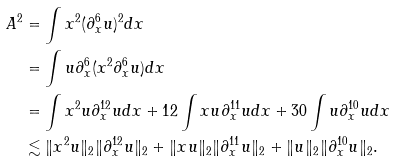Convert formula to latex. <formula><loc_0><loc_0><loc_500><loc_500>A ^ { 2 } & = \int x ^ { 2 } ( \partial _ { x } ^ { 6 } u ) ^ { 2 } d x \\ & = \int u \partial _ { x } ^ { 6 } ( x ^ { 2 } \partial _ { x } ^ { 6 } u ) d x \\ & = \int x ^ { 2 } u \partial _ { x } ^ { 1 2 } u d x + 1 2 \int x u \partial _ { x } ^ { 1 1 } u d x + 3 0 \int u \partial _ { x } ^ { 1 0 } u d x \\ & \lesssim \| x ^ { 2 } u \| _ { 2 } \| \partial _ { x } ^ { 1 2 } u \| _ { 2 } + \| x u \| _ { 2 } \| \partial _ { x } ^ { 1 1 } u \| _ { 2 } + \| u \| _ { 2 } \| \partial _ { x } ^ { 1 0 } u \| _ { 2 } .</formula> 